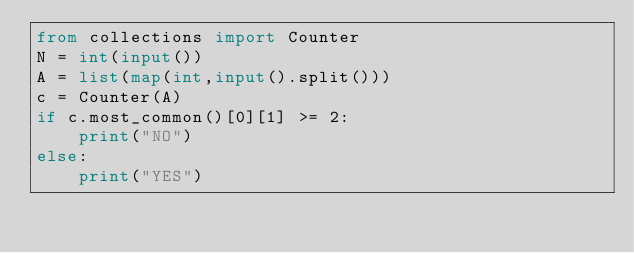Convert code to text. <code><loc_0><loc_0><loc_500><loc_500><_Python_>from collections import Counter
N = int(input())
A = list(map(int,input().split()))
c = Counter(A)
if c.most_common()[0][1] >= 2:
    print("NO")
else:
    print("YES")</code> 